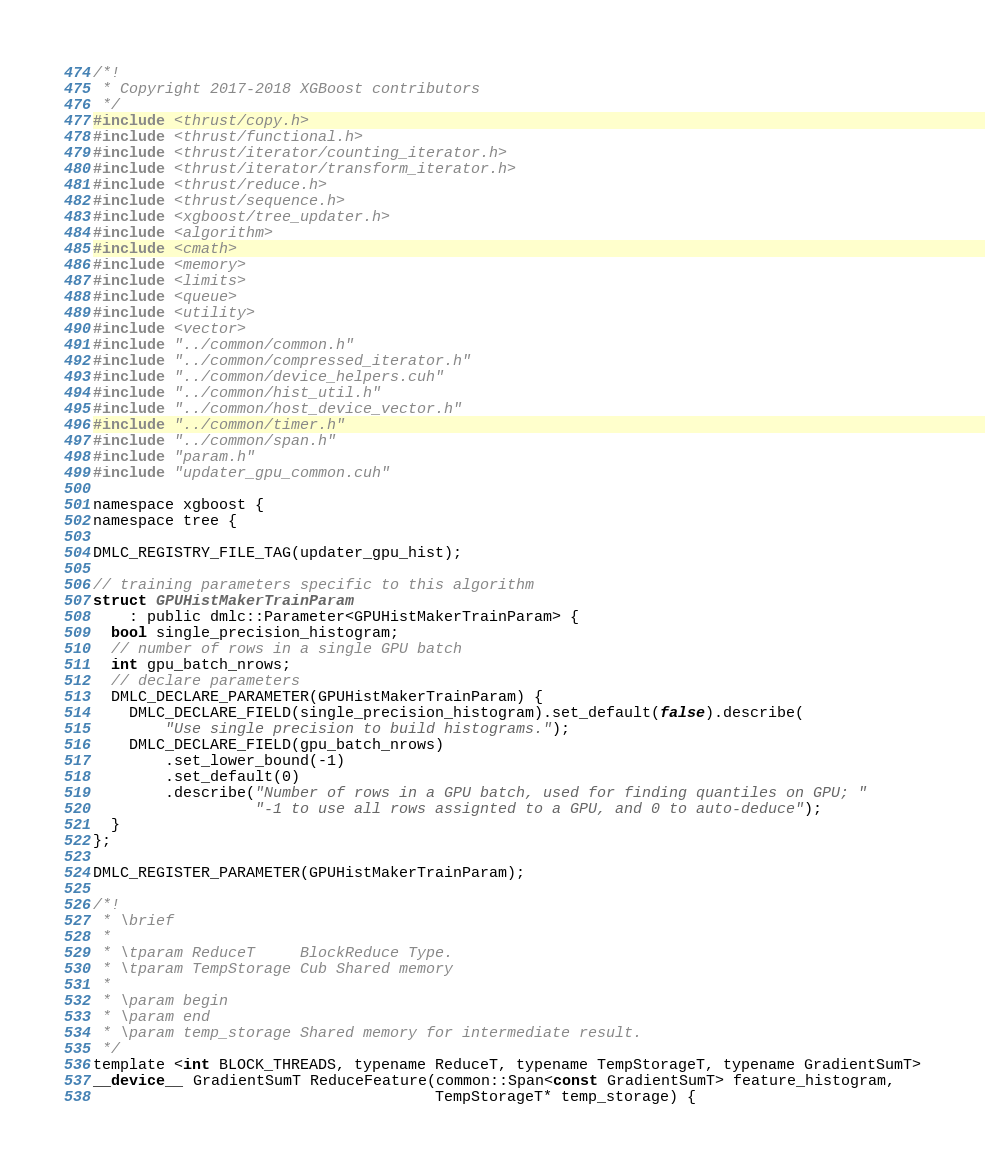<code> <loc_0><loc_0><loc_500><loc_500><_Cuda_>/*!
 * Copyright 2017-2018 XGBoost contributors
 */
#include <thrust/copy.h>
#include <thrust/functional.h>
#include <thrust/iterator/counting_iterator.h>
#include <thrust/iterator/transform_iterator.h>
#include <thrust/reduce.h>
#include <thrust/sequence.h>
#include <xgboost/tree_updater.h>
#include <algorithm>
#include <cmath>
#include <memory>
#include <limits>
#include <queue>
#include <utility>
#include <vector>
#include "../common/common.h"
#include "../common/compressed_iterator.h"
#include "../common/device_helpers.cuh"
#include "../common/hist_util.h"
#include "../common/host_device_vector.h"
#include "../common/timer.h"
#include "../common/span.h"
#include "param.h"
#include "updater_gpu_common.cuh"

namespace xgboost {
namespace tree {

DMLC_REGISTRY_FILE_TAG(updater_gpu_hist);

// training parameters specific to this algorithm
struct GPUHistMakerTrainParam
    : public dmlc::Parameter<GPUHistMakerTrainParam> {
  bool single_precision_histogram;
  // number of rows in a single GPU batch
  int gpu_batch_nrows;
  // declare parameters
  DMLC_DECLARE_PARAMETER(GPUHistMakerTrainParam) {
    DMLC_DECLARE_FIELD(single_precision_histogram).set_default(false).describe(
        "Use single precision to build histograms.");
    DMLC_DECLARE_FIELD(gpu_batch_nrows)
        .set_lower_bound(-1)
        .set_default(0)
        .describe("Number of rows in a GPU batch, used for finding quantiles on GPU; "
                  "-1 to use all rows assignted to a GPU, and 0 to auto-deduce");
  }
};

DMLC_REGISTER_PARAMETER(GPUHistMakerTrainParam);

/*!
 * \brief
 *
 * \tparam ReduceT     BlockReduce Type.
 * \tparam TempStorage Cub Shared memory
 *
 * \param begin
 * \param end
 * \param temp_storage Shared memory for intermediate result.
 */
template <int BLOCK_THREADS, typename ReduceT, typename TempStorageT, typename GradientSumT>
__device__ GradientSumT ReduceFeature(common::Span<const GradientSumT> feature_histogram,
                                      TempStorageT* temp_storage) {</code> 